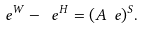<formula> <loc_0><loc_0><loc_500><loc_500>\ e ^ { W } - \ e ^ { H } = ( A \ e ) ^ { S } .</formula> 